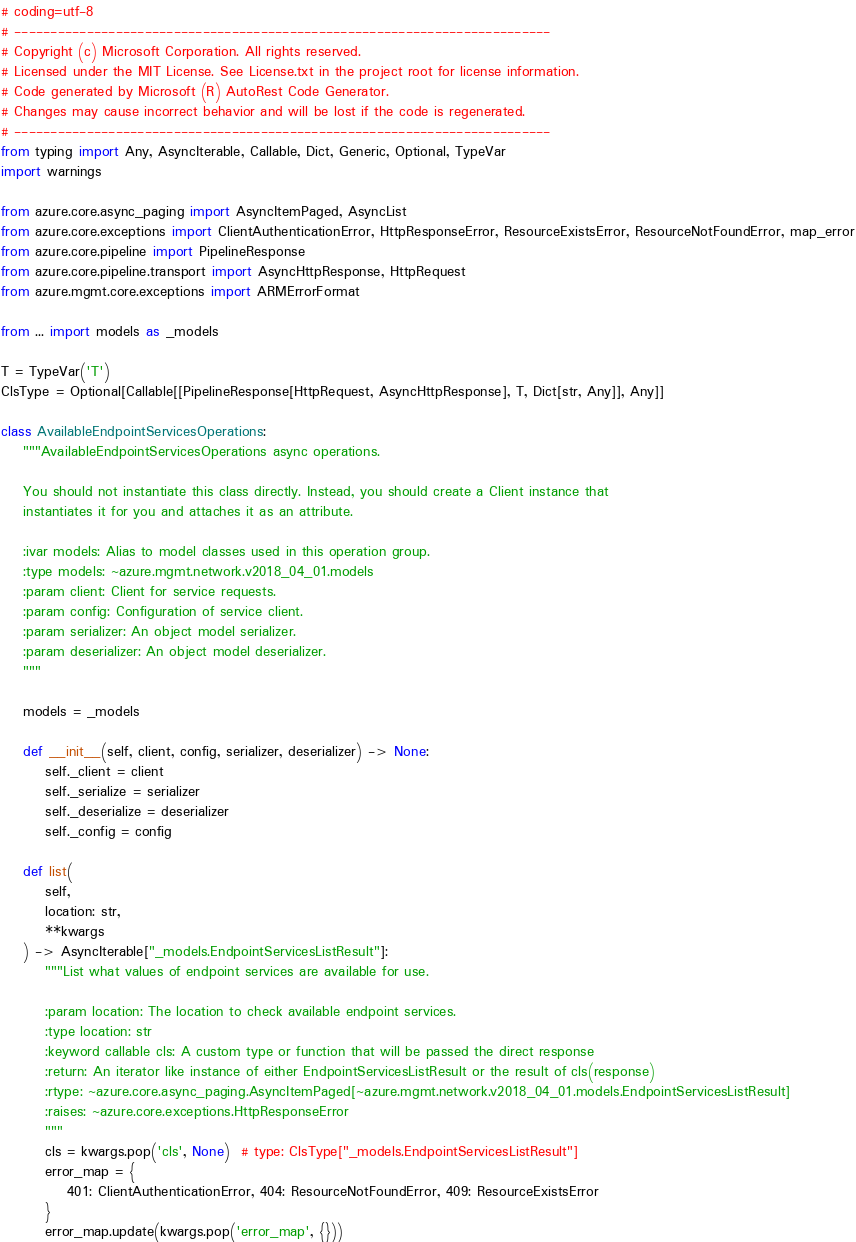Convert code to text. <code><loc_0><loc_0><loc_500><loc_500><_Python_># coding=utf-8
# --------------------------------------------------------------------------
# Copyright (c) Microsoft Corporation. All rights reserved.
# Licensed under the MIT License. See License.txt in the project root for license information.
# Code generated by Microsoft (R) AutoRest Code Generator.
# Changes may cause incorrect behavior and will be lost if the code is regenerated.
# --------------------------------------------------------------------------
from typing import Any, AsyncIterable, Callable, Dict, Generic, Optional, TypeVar
import warnings

from azure.core.async_paging import AsyncItemPaged, AsyncList
from azure.core.exceptions import ClientAuthenticationError, HttpResponseError, ResourceExistsError, ResourceNotFoundError, map_error
from azure.core.pipeline import PipelineResponse
from azure.core.pipeline.transport import AsyncHttpResponse, HttpRequest
from azure.mgmt.core.exceptions import ARMErrorFormat

from ... import models as _models

T = TypeVar('T')
ClsType = Optional[Callable[[PipelineResponse[HttpRequest, AsyncHttpResponse], T, Dict[str, Any]], Any]]

class AvailableEndpointServicesOperations:
    """AvailableEndpointServicesOperations async operations.

    You should not instantiate this class directly. Instead, you should create a Client instance that
    instantiates it for you and attaches it as an attribute.

    :ivar models: Alias to model classes used in this operation group.
    :type models: ~azure.mgmt.network.v2018_04_01.models
    :param client: Client for service requests.
    :param config: Configuration of service client.
    :param serializer: An object model serializer.
    :param deserializer: An object model deserializer.
    """

    models = _models

    def __init__(self, client, config, serializer, deserializer) -> None:
        self._client = client
        self._serialize = serializer
        self._deserialize = deserializer
        self._config = config

    def list(
        self,
        location: str,
        **kwargs
    ) -> AsyncIterable["_models.EndpointServicesListResult"]:
        """List what values of endpoint services are available for use.

        :param location: The location to check available endpoint services.
        :type location: str
        :keyword callable cls: A custom type or function that will be passed the direct response
        :return: An iterator like instance of either EndpointServicesListResult or the result of cls(response)
        :rtype: ~azure.core.async_paging.AsyncItemPaged[~azure.mgmt.network.v2018_04_01.models.EndpointServicesListResult]
        :raises: ~azure.core.exceptions.HttpResponseError
        """
        cls = kwargs.pop('cls', None)  # type: ClsType["_models.EndpointServicesListResult"]
        error_map = {
            401: ClientAuthenticationError, 404: ResourceNotFoundError, 409: ResourceExistsError
        }
        error_map.update(kwargs.pop('error_map', {}))</code> 